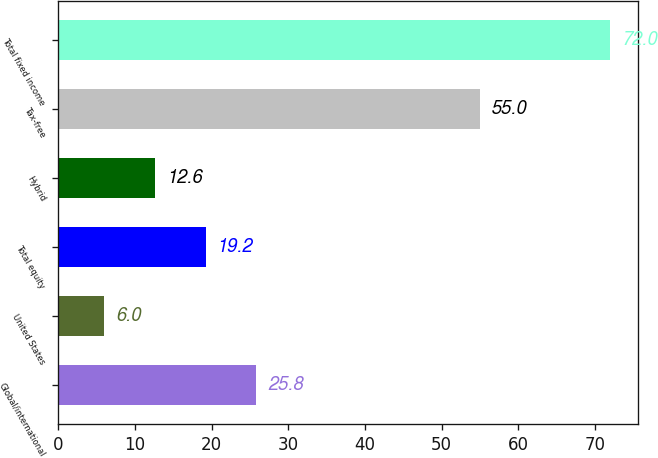<chart> <loc_0><loc_0><loc_500><loc_500><bar_chart><fcel>Global/international<fcel>United States<fcel>Total equity<fcel>Hybrid<fcel>Tax-free<fcel>Total fixed income<nl><fcel>25.8<fcel>6<fcel>19.2<fcel>12.6<fcel>55<fcel>72<nl></chart> 